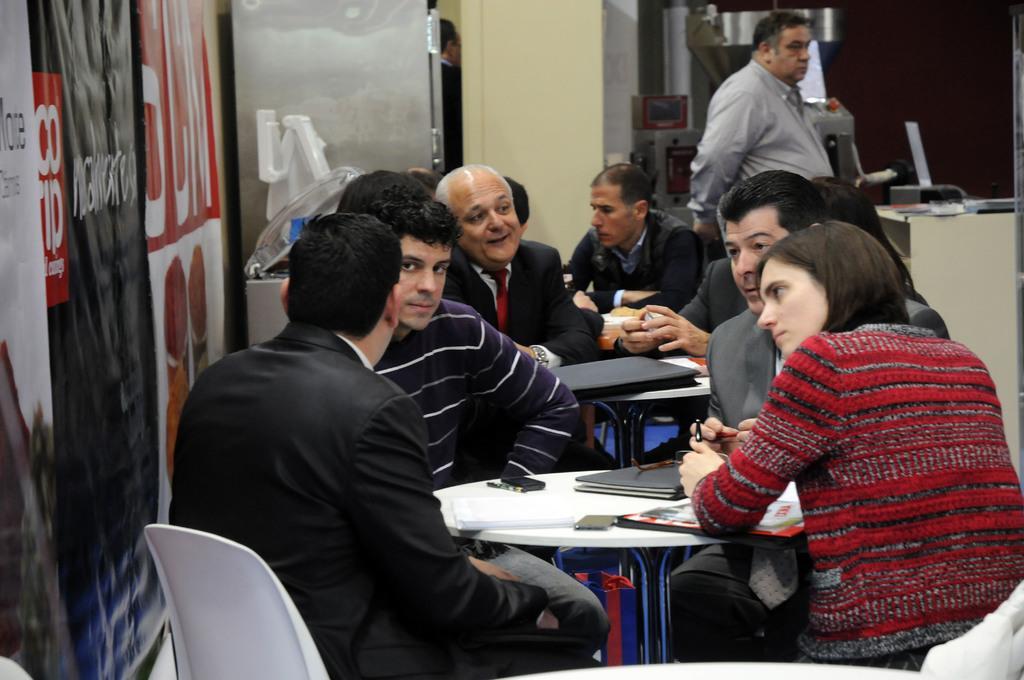Describe this image in one or two sentences. In this image there are tables, on that tables there are few objects, around the tables there are chairs, on that chairs there are people sitting, on the left side there is a banner, on that banner there is some text, in the background there is a man standing and there are few machines. 